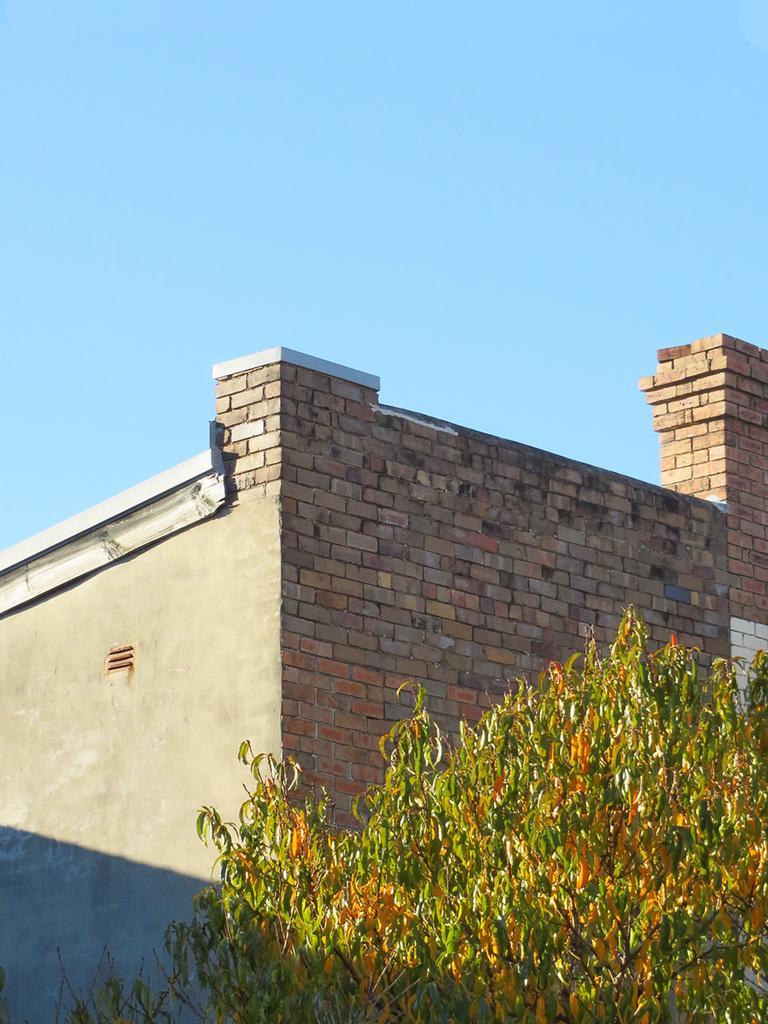In one or two sentences, can you explain what this image depicts? In the picture I can see a building and a tree. In the background I can see the sky. 